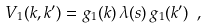<formula> <loc_0><loc_0><loc_500><loc_500>V _ { 1 } ( k , k ^ { \prime } ) = g _ { 1 } ( k ) \, \lambda ( s ) \, g _ { 1 } ( k ^ { \prime } ) \ ,</formula> 